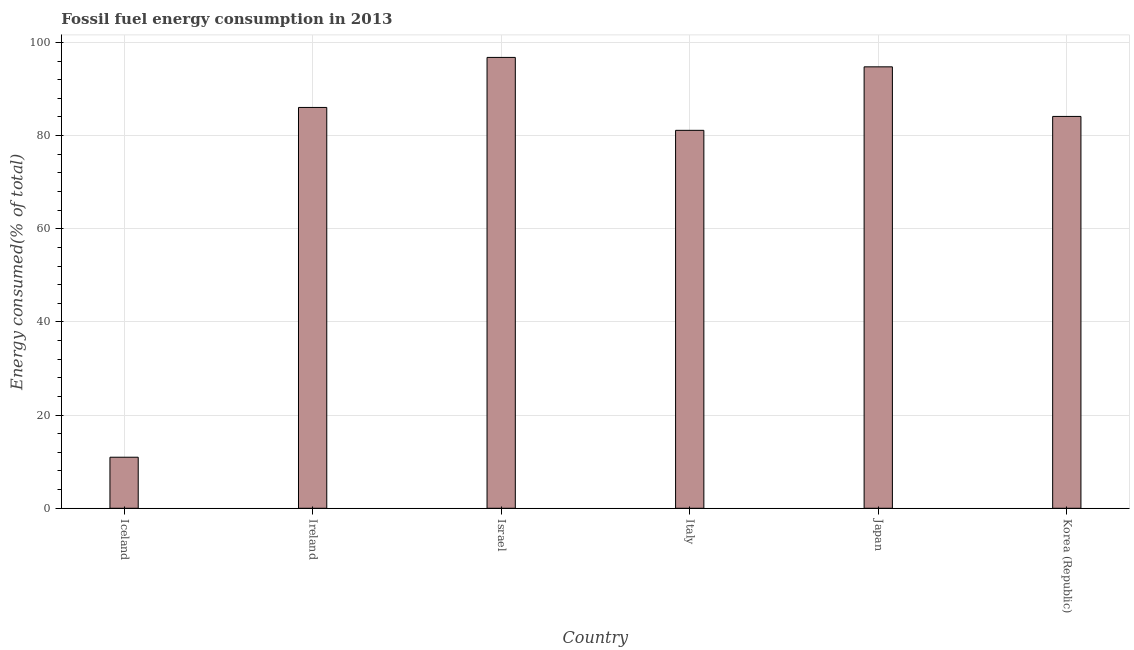Does the graph contain any zero values?
Provide a succinct answer. No. What is the title of the graph?
Offer a terse response. Fossil fuel energy consumption in 2013. What is the label or title of the X-axis?
Ensure brevity in your answer.  Country. What is the label or title of the Y-axis?
Provide a succinct answer. Energy consumed(% of total). What is the fossil fuel energy consumption in Japan?
Offer a terse response. 94.75. Across all countries, what is the maximum fossil fuel energy consumption?
Ensure brevity in your answer.  96.77. Across all countries, what is the minimum fossil fuel energy consumption?
Keep it short and to the point. 10.96. In which country was the fossil fuel energy consumption maximum?
Give a very brief answer. Israel. In which country was the fossil fuel energy consumption minimum?
Ensure brevity in your answer.  Iceland. What is the sum of the fossil fuel energy consumption?
Give a very brief answer. 453.73. What is the difference between the fossil fuel energy consumption in Iceland and Japan?
Your response must be concise. -83.79. What is the average fossil fuel energy consumption per country?
Your answer should be compact. 75.62. What is the median fossil fuel energy consumption?
Provide a succinct answer. 85.07. In how many countries, is the fossil fuel energy consumption greater than 12 %?
Offer a very short reply. 5. What is the ratio of the fossil fuel energy consumption in Italy to that in Japan?
Ensure brevity in your answer.  0.86. Is the fossil fuel energy consumption in Iceland less than that in Israel?
Make the answer very short. Yes. What is the difference between the highest and the second highest fossil fuel energy consumption?
Make the answer very short. 2.02. Is the sum of the fossil fuel energy consumption in Iceland and Italy greater than the maximum fossil fuel energy consumption across all countries?
Offer a very short reply. No. What is the difference between the highest and the lowest fossil fuel energy consumption?
Keep it short and to the point. 85.82. In how many countries, is the fossil fuel energy consumption greater than the average fossil fuel energy consumption taken over all countries?
Provide a short and direct response. 5. How many countries are there in the graph?
Offer a very short reply. 6. What is the Energy consumed(% of total) in Iceland?
Offer a terse response. 10.96. What is the Energy consumed(% of total) in Ireland?
Ensure brevity in your answer.  86.03. What is the Energy consumed(% of total) of Israel?
Keep it short and to the point. 96.77. What is the Energy consumed(% of total) in Italy?
Your answer should be very brief. 81.12. What is the Energy consumed(% of total) in Japan?
Offer a very short reply. 94.75. What is the Energy consumed(% of total) in Korea (Republic)?
Offer a very short reply. 84.1. What is the difference between the Energy consumed(% of total) in Iceland and Ireland?
Your response must be concise. -75.08. What is the difference between the Energy consumed(% of total) in Iceland and Israel?
Provide a short and direct response. -85.82. What is the difference between the Energy consumed(% of total) in Iceland and Italy?
Make the answer very short. -70.17. What is the difference between the Energy consumed(% of total) in Iceland and Japan?
Your answer should be compact. -83.79. What is the difference between the Energy consumed(% of total) in Iceland and Korea (Republic)?
Ensure brevity in your answer.  -73.15. What is the difference between the Energy consumed(% of total) in Ireland and Israel?
Offer a terse response. -10.74. What is the difference between the Energy consumed(% of total) in Ireland and Italy?
Your answer should be very brief. 4.91. What is the difference between the Energy consumed(% of total) in Ireland and Japan?
Your answer should be very brief. -8.71. What is the difference between the Energy consumed(% of total) in Ireland and Korea (Republic)?
Ensure brevity in your answer.  1.93. What is the difference between the Energy consumed(% of total) in Israel and Italy?
Give a very brief answer. 15.65. What is the difference between the Energy consumed(% of total) in Israel and Japan?
Offer a terse response. 2.02. What is the difference between the Energy consumed(% of total) in Israel and Korea (Republic)?
Your answer should be compact. 12.67. What is the difference between the Energy consumed(% of total) in Italy and Japan?
Provide a succinct answer. -13.63. What is the difference between the Energy consumed(% of total) in Italy and Korea (Republic)?
Provide a short and direct response. -2.98. What is the difference between the Energy consumed(% of total) in Japan and Korea (Republic)?
Offer a terse response. 10.64. What is the ratio of the Energy consumed(% of total) in Iceland to that in Ireland?
Your answer should be compact. 0.13. What is the ratio of the Energy consumed(% of total) in Iceland to that in Israel?
Provide a succinct answer. 0.11. What is the ratio of the Energy consumed(% of total) in Iceland to that in Italy?
Ensure brevity in your answer.  0.14. What is the ratio of the Energy consumed(% of total) in Iceland to that in Japan?
Make the answer very short. 0.12. What is the ratio of the Energy consumed(% of total) in Iceland to that in Korea (Republic)?
Provide a short and direct response. 0.13. What is the ratio of the Energy consumed(% of total) in Ireland to that in Israel?
Your response must be concise. 0.89. What is the ratio of the Energy consumed(% of total) in Ireland to that in Italy?
Make the answer very short. 1.06. What is the ratio of the Energy consumed(% of total) in Ireland to that in Japan?
Make the answer very short. 0.91. What is the ratio of the Energy consumed(% of total) in Israel to that in Italy?
Keep it short and to the point. 1.19. What is the ratio of the Energy consumed(% of total) in Israel to that in Japan?
Provide a short and direct response. 1.02. What is the ratio of the Energy consumed(% of total) in Israel to that in Korea (Republic)?
Give a very brief answer. 1.15. What is the ratio of the Energy consumed(% of total) in Italy to that in Japan?
Your answer should be compact. 0.86. What is the ratio of the Energy consumed(% of total) in Italy to that in Korea (Republic)?
Give a very brief answer. 0.96. What is the ratio of the Energy consumed(% of total) in Japan to that in Korea (Republic)?
Your answer should be very brief. 1.13. 